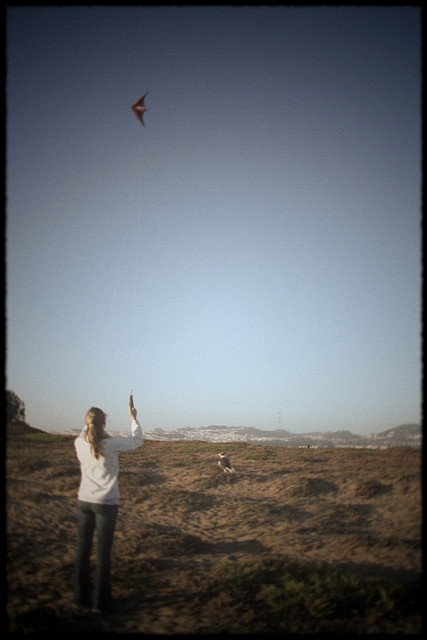Describe the objects in this image and their specific colors. I can see people in black, gray, darkgray, and lightgray tones, kite in black, maroon, gray, and purple tones, and dog in black, maroon, and gray tones in this image. 